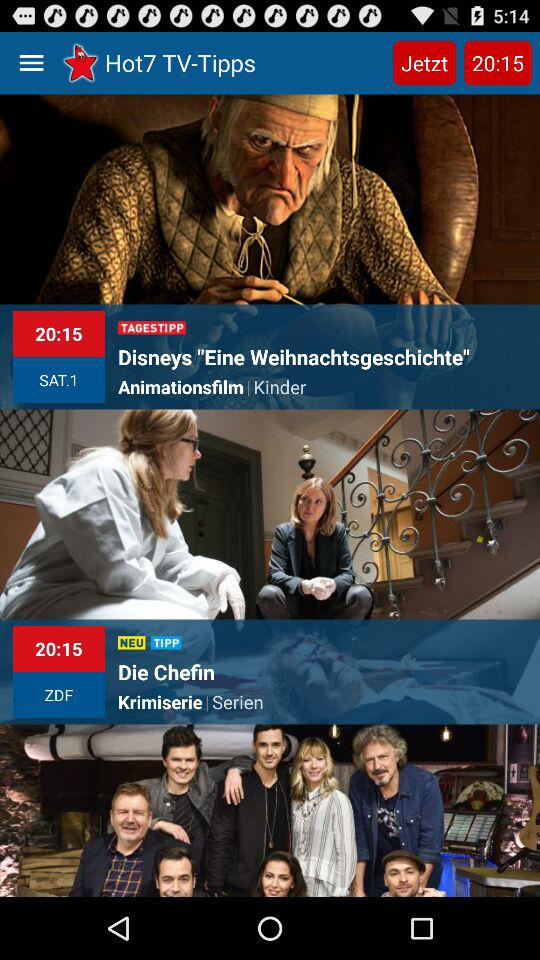What time is displayed on the application? The time is 20:15. 